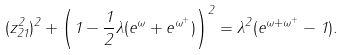Convert formula to latex. <formula><loc_0><loc_0><loc_500><loc_500>( z _ { 2 1 } ^ { 2 } ) ^ { 2 } + \left ( 1 - \frac { 1 } { 2 } \lambda ( e ^ { \omega } + e ^ { \omega ^ { + } } ) \right ) ^ { 2 } = \lambda ^ { 2 } ( e ^ { \omega + \omega ^ { + } } - 1 ) .</formula> 